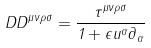Convert formula to latex. <formula><loc_0><loc_0><loc_500><loc_500>\ D D ^ { \mu \nu \rho \sigma } = \frac { \tau ^ { \mu \nu \rho \sigma } } { 1 + \epsilon u ^ { \alpha } \partial _ { \alpha } }</formula> 